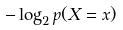Convert formula to latex. <formula><loc_0><loc_0><loc_500><loc_500>- \log _ { 2 } p ( X = x )</formula> 